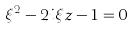Convert formula to latex. <formula><loc_0><loc_0><loc_500><loc_500>\xi ^ { 2 } - 2 i \xi z - 1 = 0</formula> 